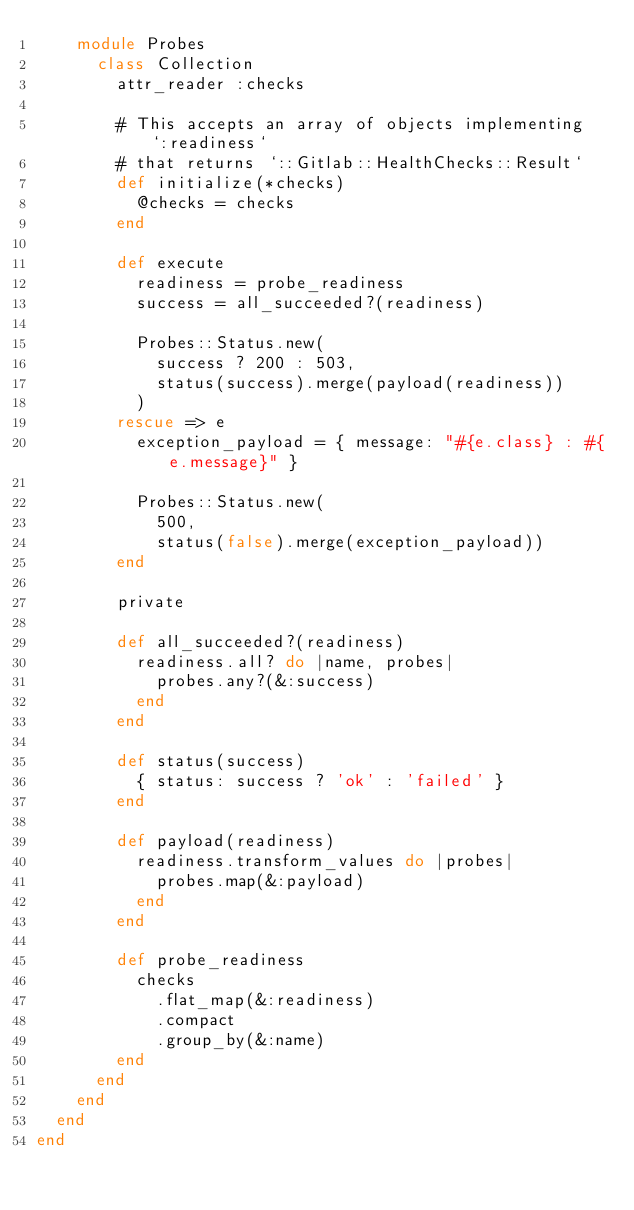<code> <loc_0><loc_0><loc_500><loc_500><_Ruby_>    module Probes
      class Collection
        attr_reader :checks

        # This accepts an array of objects implementing `:readiness`
        # that returns `::Gitlab::HealthChecks::Result`
        def initialize(*checks)
          @checks = checks
        end

        def execute
          readiness = probe_readiness
          success = all_succeeded?(readiness)

          Probes::Status.new(
            success ? 200 : 503,
            status(success).merge(payload(readiness))
          )
        rescue => e
          exception_payload = { message: "#{e.class} : #{e.message}" }

          Probes::Status.new(
            500,
            status(false).merge(exception_payload))
        end

        private

        def all_succeeded?(readiness)
          readiness.all? do |name, probes|
            probes.any?(&:success)
          end
        end

        def status(success)
          { status: success ? 'ok' : 'failed' }
        end

        def payload(readiness)
          readiness.transform_values do |probes|
            probes.map(&:payload)
          end
        end

        def probe_readiness
          checks
            .flat_map(&:readiness)
            .compact
            .group_by(&:name)
        end
      end
    end
  end
end
</code> 